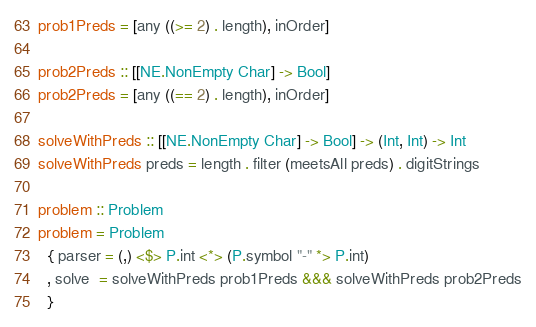<code> <loc_0><loc_0><loc_500><loc_500><_Haskell_>prob1Preds = [any ((>= 2) . length), inOrder]

prob2Preds :: [[NE.NonEmpty Char] -> Bool]
prob2Preds = [any ((== 2) . length), inOrder]

solveWithPreds :: [[NE.NonEmpty Char] -> Bool] -> (Int, Int) -> Int
solveWithPreds preds = length . filter (meetsAll preds) . digitStrings

problem :: Problem
problem = Problem
  { parser = (,) <$> P.int <*> (P.symbol "-" *> P.int)
  , solve  = solveWithPreds prob1Preds &&& solveWithPreds prob2Preds
  }
</code> 